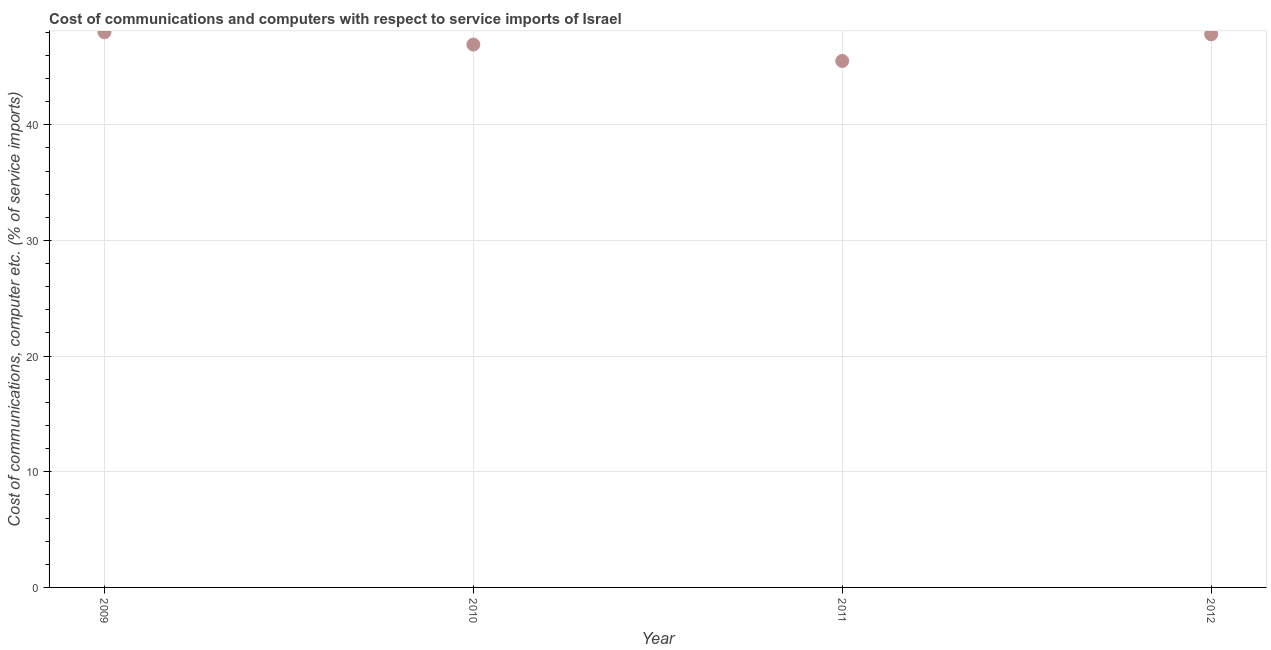What is the cost of communications and computer in 2011?
Keep it short and to the point. 45.52. Across all years, what is the maximum cost of communications and computer?
Give a very brief answer. 48. Across all years, what is the minimum cost of communications and computer?
Your response must be concise. 45.52. What is the sum of the cost of communications and computer?
Offer a terse response. 188.26. What is the difference between the cost of communications and computer in 2009 and 2012?
Your response must be concise. 0.18. What is the average cost of communications and computer per year?
Keep it short and to the point. 47.06. What is the median cost of communications and computer?
Your answer should be very brief. 47.37. In how many years, is the cost of communications and computer greater than 46 %?
Provide a short and direct response. 3. Do a majority of the years between 2009 and 2011 (inclusive) have cost of communications and computer greater than 36 %?
Your answer should be very brief. Yes. What is the ratio of the cost of communications and computer in 2010 to that in 2012?
Ensure brevity in your answer.  0.98. Is the cost of communications and computer in 2009 less than that in 2010?
Offer a very short reply. No. Is the difference between the cost of communications and computer in 2009 and 2012 greater than the difference between any two years?
Offer a terse response. No. What is the difference between the highest and the second highest cost of communications and computer?
Offer a terse response. 0.18. Is the sum of the cost of communications and computer in 2009 and 2012 greater than the maximum cost of communications and computer across all years?
Ensure brevity in your answer.  Yes. What is the difference between the highest and the lowest cost of communications and computer?
Provide a succinct answer. 2.48. In how many years, is the cost of communications and computer greater than the average cost of communications and computer taken over all years?
Keep it short and to the point. 2. Does the cost of communications and computer monotonically increase over the years?
Your answer should be compact. No. What is the difference between two consecutive major ticks on the Y-axis?
Give a very brief answer. 10. Are the values on the major ticks of Y-axis written in scientific E-notation?
Offer a very short reply. No. Does the graph contain any zero values?
Ensure brevity in your answer.  No. Does the graph contain grids?
Your response must be concise. Yes. What is the title of the graph?
Provide a succinct answer. Cost of communications and computers with respect to service imports of Israel. What is the label or title of the X-axis?
Provide a succinct answer. Year. What is the label or title of the Y-axis?
Provide a succinct answer. Cost of communications, computer etc. (% of service imports). What is the Cost of communications, computer etc. (% of service imports) in 2009?
Make the answer very short. 48. What is the Cost of communications, computer etc. (% of service imports) in 2010?
Ensure brevity in your answer.  46.93. What is the Cost of communications, computer etc. (% of service imports) in 2011?
Ensure brevity in your answer.  45.52. What is the Cost of communications, computer etc. (% of service imports) in 2012?
Keep it short and to the point. 47.82. What is the difference between the Cost of communications, computer etc. (% of service imports) in 2009 and 2010?
Provide a succinct answer. 1.06. What is the difference between the Cost of communications, computer etc. (% of service imports) in 2009 and 2011?
Keep it short and to the point. 2.48. What is the difference between the Cost of communications, computer etc. (% of service imports) in 2009 and 2012?
Provide a short and direct response. 0.18. What is the difference between the Cost of communications, computer etc. (% of service imports) in 2010 and 2011?
Provide a succinct answer. 1.42. What is the difference between the Cost of communications, computer etc. (% of service imports) in 2010 and 2012?
Ensure brevity in your answer.  -0.88. What is the difference between the Cost of communications, computer etc. (% of service imports) in 2011 and 2012?
Ensure brevity in your answer.  -2.3. What is the ratio of the Cost of communications, computer etc. (% of service imports) in 2009 to that in 2010?
Provide a succinct answer. 1.02. What is the ratio of the Cost of communications, computer etc. (% of service imports) in 2009 to that in 2011?
Give a very brief answer. 1.05. What is the ratio of the Cost of communications, computer etc. (% of service imports) in 2010 to that in 2011?
Provide a succinct answer. 1.03. What is the ratio of the Cost of communications, computer etc. (% of service imports) in 2010 to that in 2012?
Make the answer very short. 0.98. 